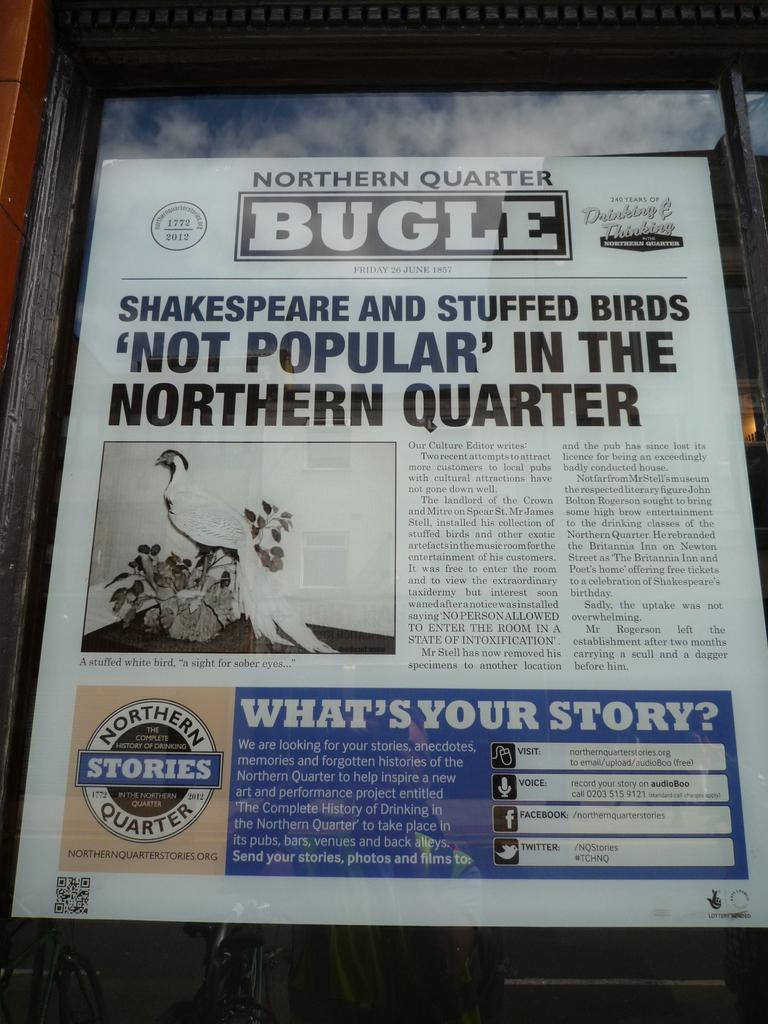<image>
Present a compact description of the photo's key features. The front page of the Norther Quarter Bugle on display. 